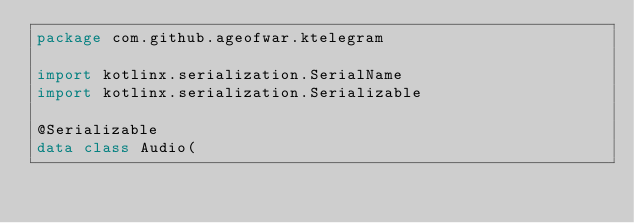<code> <loc_0><loc_0><loc_500><loc_500><_Kotlin_>package com.github.ageofwar.ktelegram

import kotlinx.serialization.SerialName
import kotlinx.serialization.Serializable

@Serializable
data class Audio(</code> 